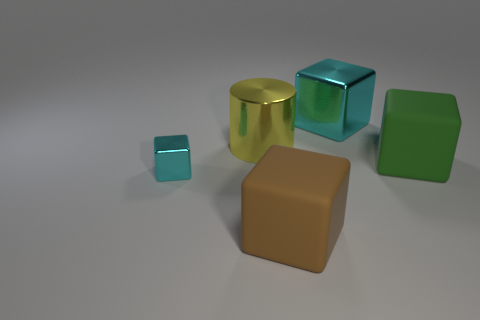If we were to sort these objects by size, how would they be ordered? Starting with the smallest, the order would be the tiny turquoise cube, the green parallelogram, the large turquoise cube, the golden cylinder, and lastly, the large brown cube, which is the largest. 